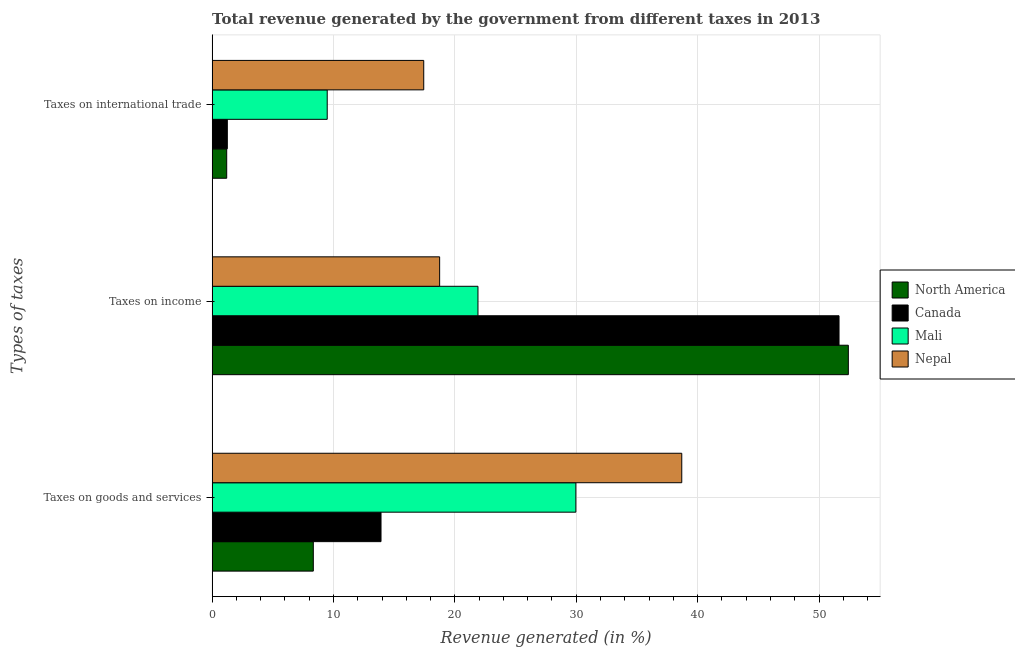How many groups of bars are there?
Your answer should be very brief. 3. Are the number of bars on each tick of the Y-axis equal?
Give a very brief answer. Yes. How many bars are there on the 2nd tick from the bottom?
Your response must be concise. 4. What is the label of the 1st group of bars from the top?
Make the answer very short. Taxes on international trade. What is the percentage of revenue generated by taxes on goods and services in North America?
Make the answer very short. 8.34. Across all countries, what is the maximum percentage of revenue generated by taxes on goods and services?
Ensure brevity in your answer.  38.69. Across all countries, what is the minimum percentage of revenue generated by taxes on income?
Keep it short and to the point. 18.74. In which country was the percentage of revenue generated by taxes on goods and services maximum?
Ensure brevity in your answer.  Nepal. What is the total percentage of revenue generated by taxes on goods and services in the graph?
Your answer should be very brief. 90.91. What is the difference between the percentage of revenue generated by tax on international trade in Nepal and that in North America?
Provide a succinct answer. 16.23. What is the difference between the percentage of revenue generated by taxes on income in North America and the percentage of revenue generated by tax on international trade in Nepal?
Your response must be concise. 34.98. What is the average percentage of revenue generated by taxes on goods and services per country?
Your answer should be compact. 22.73. What is the difference between the percentage of revenue generated by taxes on goods and services and percentage of revenue generated by tax on international trade in Nepal?
Ensure brevity in your answer.  21.26. What is the ratio of the percentage of revenue generated by tax on international trade in North America to that in Canada?
Keep it short and to the point. 0.96. Is the percentage of revenue generated by taxes on income in Nepal less than that in Canada?
Your response must be concise. Yes. Is the difference between the percentage of revenue generated by taxes on income in Canada and North America greater than the difference between the percentage of revenue generated by taxes on goods and services in Canada and North America?
Your answer should be very brief. No. What is the difference between the highest and the second highest percentage of revenue generated by tax on international trade?
Keep it short and to the point. 7.95. What is the difference between the highest and the lowest percentage of revenue generated by taxes on goods and services?
Ensure brevity in your answer.  30.36. In how many countries, is the percentage of revenue generated by taxes on income greater than the average percentage of revenue generated by taxes on income taken over all countries?
Make the answer very short. 2. What does the 2nd bar from the bottom in Taxes on international trade represents?
Your response must be concise. Canada. How many bars are there?
Make the answer very short. 12. Are all the bars in the graph horizontal?
Ensure brevity in your answer.  Yes. How many countries are there in the graph?
Your answer should be very brief. 4. Does the graph contain grids?
Your answer should be compact. Yes. What is the title of the graph?
Offer a very short reply. Total revenue generated by the government from different taxes in 2013. What is the label or title of the X-axis?
Your response must be concise. Revenue generated (in %). What is the label or title of the Y-axis?
Your answer should be very brief. Types of taxes. What is the Revenue generated (in %) of North America in Taxes on goods and services?
Provide a short and direct response. 8.34. What is the Revenue generated (in %) of Canada in Taxes on goods and services?
Offer a very short reply. 13.91. What is the Revenue generated (in %) in Mali in Taxes on goods and services?
Offer a very short reply. 29.97. What is the Revenue generated (in %) of Nepal in Taxes on goods and services?
Offer a very short reply. 38.69. What is the Revenue generated (in %) in North America in Taxes on income?
Give a very brief answer. 52.42. What is the Revenue generated (in %) of Canada in Taxes on income?
Your answer should be very brief. 51.65. What is the Revenue generated (in %) in Mali in Taxes on income?
Give a very brief answer. 21.9. What is the Revenue generated (in %) of Nepal in Taxes on income?
Provide a short and direct response. 18.74. What is the Revenue generated (in %) in North America in Taxes on international trade?
Your answer should be very brief. 1.2. What is the Revenue generated (in %) in Canada in Taxes on international trade?
Keep it short and to the point. 1.25. What is the Revenue generated (in %) of Mali in Taxes on international trade?
Make the answer very short. 9.48. What is the Revenue generated (in %) in Nepal in Taxes on international trade?
Provide a succinct answer. 17.43. Across all Types of taxes, what is the maximum Revenue generated (in %) in North America?
Offer a very short reply. 52.42. Across all Types of taxes, what is the maximum Revenue generated (in %) in Canada?
Ensure brevity in your answer.  51.65. Across all Types of taxes, what is the maximum Revenue generated (in %) of Mali?
Your answer should be very brief. 29.97. Across all Types of taxes, what is the maximum Revenue generated (in %) in Nepal?
Give a very brief answer. 38.69. Across all Types of taxes, what is the minimum Revenue generated (in %) in North America?
Ensure brevity in your answer.  1.2. Across all Types of taxes, what is the minimum Revenue generated (in %) of Canada?
Your answer should be very brief. 1.25. Across all Types of taxes, what is the minimum Revenue generated (in %) of Mali?
Your answer should be compact. 9.48. Across all Types of taxes, what is the minimum Revenue generated (in %) in Nepal?
Your response must be concise. 17.43. What is the total Revenue generated (in %) of North America in the graph?
Your response must be concise. 61.95. What is the total Revenue generated (in %) of Canada in the graph?
Provide a short and direct response. 66.82. What is the total Revenue generated (in %) of Mali in the graph?
Offer a terse response. 61.35. What is the total Revenue generated (in %) of Nepal in the graph?
Provide a succinct answer. 74.87. What is the difference between the Revenue generated (in %) of North America in Taxes on goods and services and that in Taxes on income?
Your answer should be compact. -44.08. What is the difference between the Revenue generated (in %) in Canada in Taxes on goods and services and that in Taxes on income?
Provide a succinct answer. -37.73. What is the difference between the Revenue generated (in %) of Mali in Taxes on goods and services and that in Taxes on income?
Offer a very short reply. 8.06. What is the difference between the Revenue generated (in %) of Nepal in Taxes on goods and services and that in Taxes on income?
Make the answer very short. 19.95. What is the difference between the Revenue generated (in %) of North America in Taxes on goods and services and that in Taxes on international trade?
Offer a terse response. 7.14. What is the difference between the Revenue generated (in %) of Canada in Taxes on goods and services and that in Taxes on international trade?
Your answer should be very brief. 12.66. What is the difference between the Revenue generated (in %) of Mali in Taxes on goods and services and that in Taxes on international trade?
Provide a short and direct response. 20.48. What is the difference between the Revenue generated (in %) of Nepal in Taxes on goods and services and that in Taxes on international trade?
Ensure brevity in your answer.  21.26. What is the difference between the Revenue generated (in %) in North America in Taxes on income and that in Taxes on international trade?
Make the answer very short. 51.21. What is the difference between the Revenue generated (in %) of Canada in Taxes on income and that in Taxes on international trade?
Your answer should be very brief. 50.4. What is the difference between the Revenue generated (in %) of Mali in Taxes on income and that in Taxes on international trade?
Make the answer very short. 12.42. What is the difference between the Revenue generated (in %) in Nepal in Taxes on income and that in Taxes on international trade?
Provide a succinct answer. 1.31. What is the difference between the Revenue generated (in %) of North America in Taxes on goods and services and the Revenue generated (in %) of Canada in Taxes on income?
Your answer should be very brief. -43.31. What is the difference between the Revenue generated (in %) of North America in Taxes on goods and services and the Revenue generated (in %) of Mali in Taxes on income?
Your answer should be very brief. -13.57. What is the difference between the Revenue generated (in %) of North America in Taxes on goods and services and the Revenue generated (in %) of Nepal in Taxes on income?
Ensure brevity in your answer.  -10.41. What is the difference between the Revenue generated (in %) of Canada in Taxes on goods and services and the Revenue generated (in %) of Mali in Taxes on income?
Provide a succinct answer. -7.99. What is the difference between the Revenue generated (in %) of Canada in Taxes on goods and services and the Revenue generated (in %) of Nepal in Taxes on income?
Offer a very short reply. -4.83. What is the difference between the Revenue generated (in %) of Mali in Taxes on goods and services and the Revenue generated (in %) of Nepal in Taxes on income?
Your response must be concise. 11.22. What is the difference between the Revenue generated (in %) of North America in Taxes on goods and services and the Revenue generated (in %) of Canada in Taxes on international trade?
Provide a succinct answer. 7.08. What is the difference between the Revenue generated (in %) of North America in Taxes on goods and services and the Revenue generated (in %) of Mali in Taxes on international trade?
Your answer should be compact. -1.15. What is the difference between the Revenue generated (in %) of North America in Taxes on goods and services and the Revenue generated (in %) of Nepal in Taxes on international trade?
Give a very brief answer. -9.1. What is the difference between the Revenue generated (in %) in Canada in Taxes on goods and services and the Revenue generated (in %) in Mali in Taxes on international trade?
Ensure brevity in your answer.  4.43. What is the difference between the Revenue generated (in %) of Canada in Taxes on goods and services and the Revenue generated (in %) of Nepal in Taxes on international trade?
Give a very brief answer. -3.52. What is the difference between the Revenue generated (in %) in Mali in Taxes on goods and services and the Revenue generated (in %) in Nepal in Taxes on international trade?
Give a very brief answer. 12.53. What is the difference between the Revenue generated (in %) in North America in Taxes on income and the Revenue generated (in %) in Canada in Taxes on international trade?
Provide a short and direct response. 51.16. What is the difference between the Revenue generated (in %) in North America in Taxes on income and the Revenue generated (in %) in Mali in Taxes on international trade?
Ensure brevity in your answer.  42.93. What is the difference between the Revenue generated (in %) in North America in Taxes on income and the Revenue generated (in %) in Nepal in Taxes on international trade?
Ensure brevity in your answer.  34.98. What is the difference between the Revenue generated (in %) of Canada in Taxes on income and the Revenue generated (in %) of Mali in Taxes on international trade?
Your response must be concise. 42.17. What is the difference between the Revenue generated (in %) of Canada in Taxes on income and the Revenue generated (in %) of Nepal in Taxes on international trade?
Your response must be concise. 34.22. What is the difference between the Revenue generated (in %) in Mali in Taxes on income and the Revenue generated (in %) in Nepal in Taxes on international trade?
Provide a succinct answer. 4.47. What is the average Revenue generated (in %) in North America per Types of taxes?
Give a very brief answer. 20.65. What is the average Revenue generated (in %) of Canada per Types of taxes?
Your answer should be compact. 22.27. What is the average Revenue generated (in %) of Mali per Types of taxes?
Offer a very short reply. 20.45. What is the average Revenue generated (in %) of Nepal per Types of taxes?
Provide a short and direct response. 24.96. What is the difference between the Revenue generated (in %) of North America and Revenue generated (in %) of Canada in Taxes on goods and services?
Keep it short and to the point. -5.58. What is the difference between the Revenue generated (in %) in North America and Revenue generated (in %) in Mali in Taxes on goods and services?
Ensure brevity in your answer.  -21.63. What is the difference between the Revenue generated (in %) of North America and Revenue generated (in %) of Nepal in Taxes on goods and services?
Make the answer very short. -30.36. What is the difference between the Revenue generated (in %) of Canada and Revenue generated (in %) of Mali in Taxes on goods and services?
Offer a terse response. -16.05. What is the difference between the Revenue generated (in %) of Canada and Revenue generated (in %) of Nepal in Taxes on goods and services?
Make the answer very short. -24.78. What is the difference between the Revenue generated (in %) in Mali and Revenue generated (in %) in Nepal in Taxes on goods and services?
Offer a very short reply. -8.73. What is the difference between the Revenue generated (in %) of North America and Revenue generated (in %) of Canada in Taxes on income?
Offer a very short reply. 0.77. What is the difference between the Revenue generated (in %) in North America and Revenue generated (in %) in Mali in Taxes on income?
Provide a short and direct response. 30.51. What is the difference between the Revenue generated (in %) of North America and Revenue generated (in %) of Nepal in Taxes on income?
Your answer should be compact. 33.67. What is the difference between the Revenue generated (in %) of Canada and Revenue generated (in %) of Mali in Taxes on income?
Offer a very short reply. 29.75. What is the difference between the Revenue generated (in %) of Canada and Revenue generated (in %) of Nepal in Taxes on income?
Your answer should be compact. 32.9. What is the difference between the Revenue generated (in %) in Mali and Revenue generated (in %) in Nepal in Taxes on income?
Your answer should be compact. 3.16. What is the difference between the Revenue generated (in %) in North America and Revenue generated (in %) in Canada in Taxes on international trade?
Your answer should be very brief. -0.05. What is the difference between the Revenue generated (in %) of North America and Revenue generated (in %) of Mali in Taxes on international trade?
Your answer should be compact. -8.28. What is the difference between the Revenue generated (in %) in North America and Revenue generated (in %) in Nepal in Taxes on international trade?
Make the answer very short. -16.23. What is the difference between the Revenue generated (in %) of Canada and Revenue generated (in %) of Mali in Taxes on international trade?
Provide a short and direct response. -8.23. What is the difference between the Revenue generated (in %) in Canada and Revenue generated (in %) in Nepal in Taxes on international trade?
Ensure brevity in your answer.  -16.18. What is the difference between the Revenue generated (in %) in Mali and Revenue generated (in %) in Nepal in Taxes on international trade?
Make the answer very short. -7.95. What is the ratio of the Revenue generated (in %) in North America in Taxes on goods and services to that in Taxes on income?
Offer a very short reply. 0.16. What is the ratio of the Revenue generated (in %) of Canada in Taxes on goods and services to that in Taxes on income?
Ensure brevity in your answer.  0.27. What is the ratio of the Revenue generated (in %) of Mali in Taxes on goods and services to that in Taxes on income?
Your answer should be very brief. 1.37. What is the ratio of the Revenue generated (in %) of Nepal in Taxes on goods and services to that in Taxes on income?
Keep it short and to the point. 2.06. What is the ratio of the Revenue generated (in %) of North America in Taxes on goods and services to that in Taxes on international trade?
Your response must be concise. 6.94. What is the ratio of the Revenue generated (in %) in Canada in Taxes on goods and services to that in Taxes on international trade?
Provide a short and direct response. 11.11. What is the ratio of the Revenue generated (in %) in Mali in Taxes on goods and services to that in Taxes on international trade?
Ensure brevity in your answer.  3.16. What is the ratio of the Revenue generated (in %) in Nepal in Taxes on goods and services to that in Taxes on international trade?
Your answer should be very brief. 2.22. What is the ratio of the Revenue generated (in %) in North America in Taxes on income to that in Taxes on international trade?
Give a very brief answer. 43.63. What is the ratio of the Revenue generated (in %) of Canada in Taxes on income to that in Taxes on international trade?
Your answer should be very brief. 41.24. What is the ratio of the Revenue generated (in %) of Mali in Taxes on income to that in Taxes on international trade?
Make the answer very short. 2.31. What is the ratio of the Revenue generated (in %) in Nepal in Taxes on income to that in Taxes on international trade?
Provide a succinct answer. 1.08. What is the difference between the highest and the second highest Revenue generated (in %) in North America?
Provide a short and direct response. 44.08. What is the difference between the highest and the second highest Revenue generated (in %) of Canada?
Your answer should be compact. 37.73. What is the difference between the highest and the second highest Revenue generated (in %) of Mali?
Your answer should be compact. 8.06. What is the difference between the highest and the second highest Revenue generated (in %) in Nepal?
Provide a succinct answer. 19.95. What is the difference between the highest and the lowest Revenue generated (in %) in North America?
Provide a succinct answer. 51.21. What is the difference between the highest and the lowest Revenue generated (in %) of Canada?
Provide a short and direct response. 50.4. What is the difference between the highest and the lowest Revenue generated (in %) in Mali?
Provide a succinct answer. 20.48. What is the difference between the highest and the lowest Revenue generated (in %) in Nepal?
Offer a terse response. 21.26. 